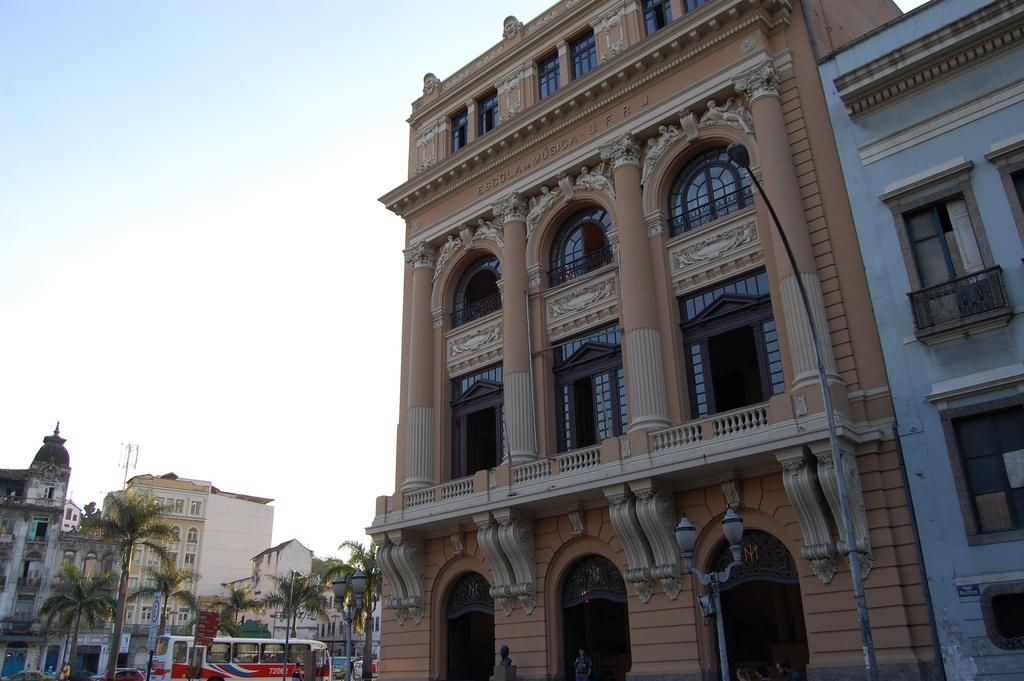What can be seen on the right side of the image in the foreground? There are light poles and buildings on the right side of the image in the foreground. What is visible in the background of the image? In the background, there are trees, buildings, a bus, boards, a tower, and the sky. Can you describe the buildings in the image? There are buildings in both the foreground and background of the image. What type of structure is visible in the background of the image? There is a tower in the background of the image. What type of memory is stored in the house in the image? There is no house present in the image, so it is not possible to determine what type of memory might be stored in a house. What type of destruction can be seen in the image? There is no destruction present in the image; it features light poles, buildings, trees, and other structures in various locations. 